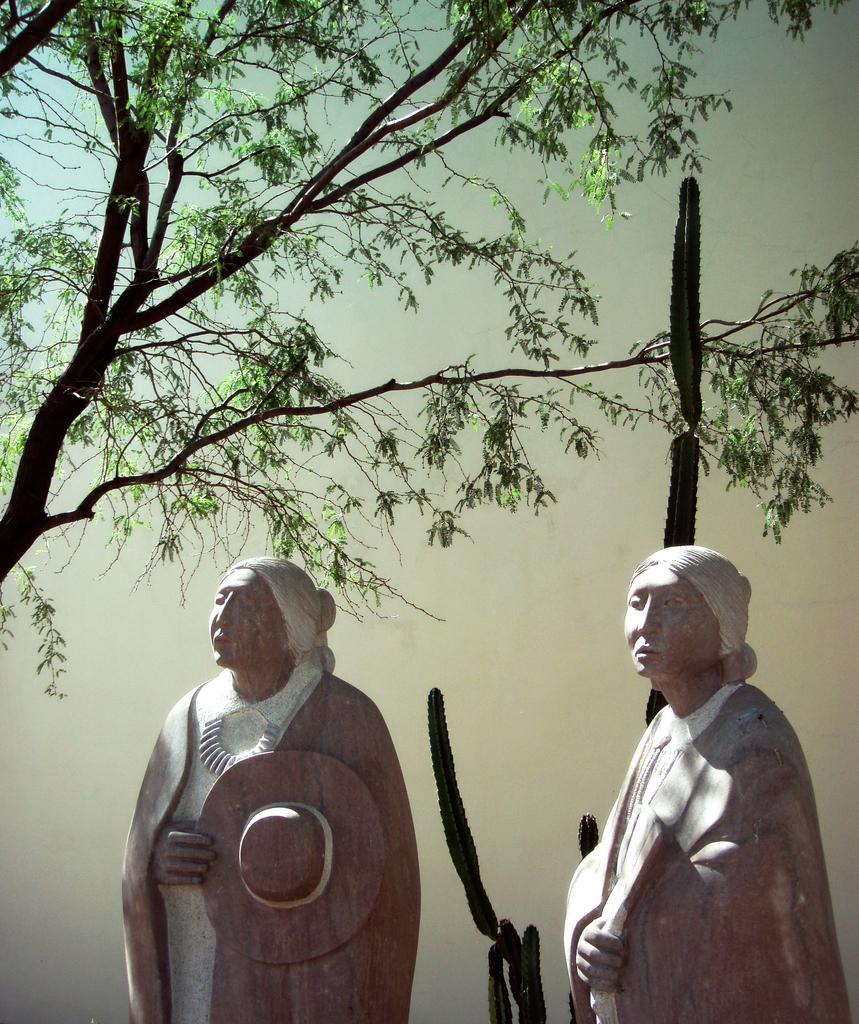What type of objects can be seen in the image? There are statues in the image. What other elements are present in the image besides the statues? There are trees in the image. What can be seen in the background of the image? The sky is visible in the image. What type of sweater is the rabbit wearing in the image? There is no rabbit or sweater present in the image. How many books can be seen on the ground in the image? There are no books present in the image. 